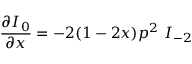Convert formula to latex. <formula><loc_0><loc_0><loc_500><loc_500>\frac { \partial I _ { 0 } } { \partial x } = - 2 ( 1 - 2 x ) p ^ { 2 } \ I _ { - 2 }</formula> 